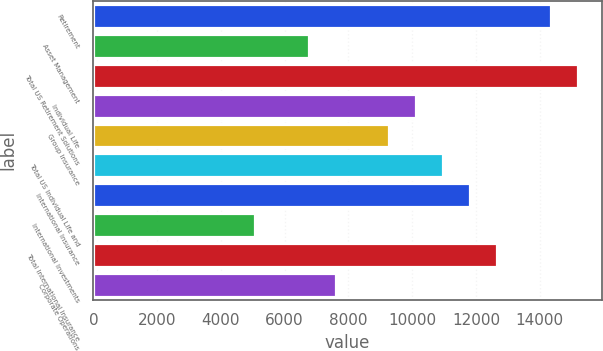<chart> <loc_0><loc_0><loc_500><loc_500><bar_chart><fcel>Retirement<fcel>Asset Management<fcel>Total US Retirement Solutions<fcel>Individual Life<fcel>Group Insurance<fcel>Total US Individual Life and<fcel>International Insurance<fcel>International Investments<fcel>Total International Insurance<fcel>Corporate Operations<nl><fcel>14347.8<fcel>6752.12<fcel>15191.7<fcel>10128<fcel>9284<fcel>10971.9<fcel>11815.9<fcel>5064.2<fcel>12659.8<fcel>7596.08<nl></chart> 